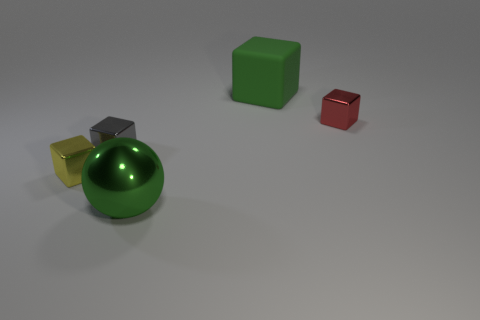Are there any matte spheres that have the same color as the matte object?
Make the answer very short. No. There is a red object that is the same size as the yellow cube; what shape is it?
Give a very brief answer. Cube. What number of spheres are right of the metal thing that is in front of the yellow metal thing?
Provide a succinct answer. 0. Does the big matte object have the same color as the shiny ball?
Provide a succinct answer. Yes. How many other objects are the same material as the red cube?
Provide a succinct answer. 3. What is the shape of the thing behind the tiny red metallic thing that is behind the large green metal sphere?
Provide a succinct answer. Cube. What is the size of the gray metallic block that is to the right of the tiny yellow cube?
Give a very brief answer. Small. Do the yellow thing and the tiny red cube have the same material?
Your answer should be compact. Yes. What shape is the tiny red thing that is the same material as the small yellow cube?
Provide a short and direct response. Cube. Is there any other thing that is the same color as the metal ball?
Your response must be concise. Yes. 